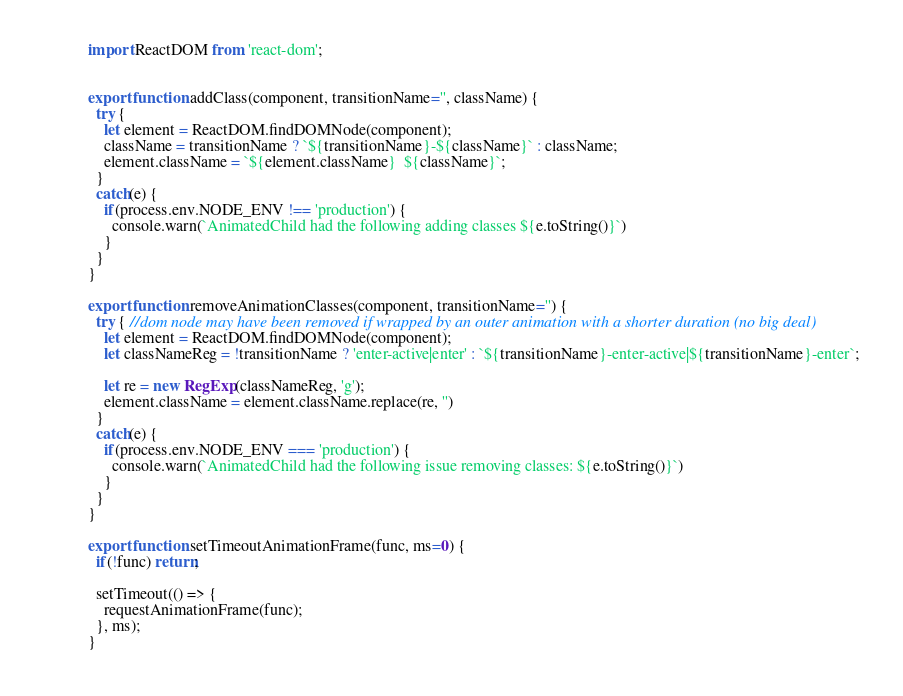<code> <loc_0><loc_0><loc_500><loc_500><_JavaScript_>import ReactDOM from 'react-dom';


export function addClass(component, transitionName='', className) {
  try { 
    let element = ReactDOM.findDOMNode(component);
    className = transitionName ? `${transitionName}-${className}` : className;
    element.className = `${element.className}  ${className}`;
  }
  catch(e) {
    if(process.env.NODE_ENV !== 'production') {
      console.warn(`AnimatedChild had the following adding classes ${e.toString()}`)
    }
  }
}

export function removeAnimationClasses(component, transitionName='') {
  try { //dom node may have been removed if wrapped by an outer animation with a shorter duration (no big deal)
    let element = ReactDOM.findDOMNode(component);
    let classNameReg = !transitionName ? 'enter-active|enter' : `${transitionName}-enter-active|${transitionName}-enter`;

    let re = new RegExp(classNameReg, 'g');
    element.className = element.className.replace(re, '')
  }
  catch(e) {
    if(process.env.NODE_ENV === 'production') {
      console.warn(`AnimatedChild had the following issue removing classes: ${e.toString()}`)
    }
  }
}

export function setTimeoutAnimationFrame(func, ms=0) {
  if(!func) return;

  setTimeout(() => {
    requestAnimationFrame(func);
  }, ms);
}</code> 